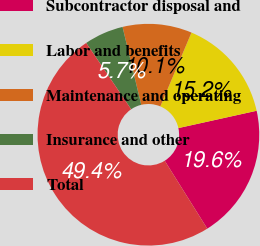<chart> <loc_0><loc_0><loc_500><loc_500><pie_chart><fcel>Subcontractor disposal and<fcel>Labor and benefits<fcel>Maintenance and operating<fcel>Insurance and other<fcel>Total<nl><fcel>19.55%<fcel>15.18%<fcel>10.1%<fcel>5.73%<fcel>49.43%<nl></chart> 